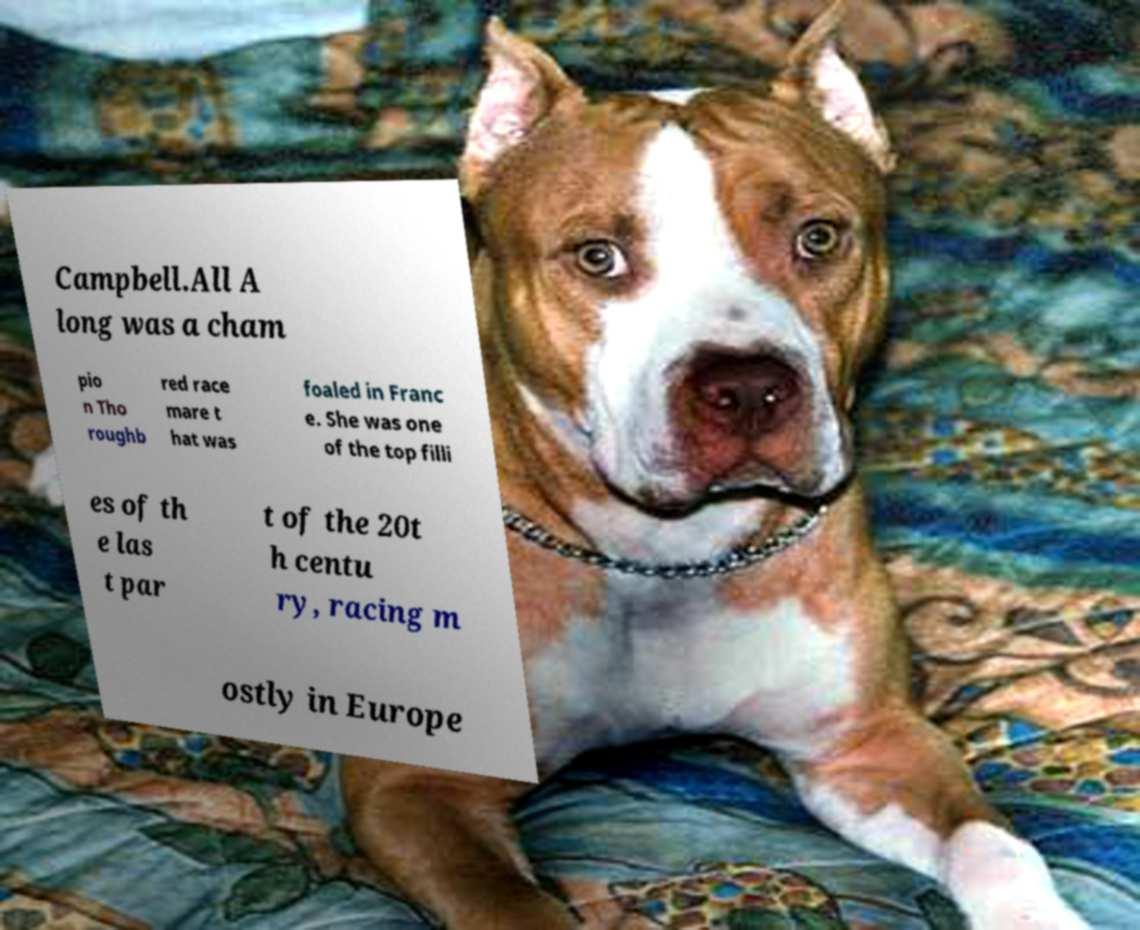Could you assist in decoding the text presented in this image and type it out clearly? Campbell.All A long was a cham pio n Tho roughb red race mare t hat was foaled in Franc e. She was one of the top filli es of th e las t par t of the 20t h centu ry, racing m ostly in Europe 